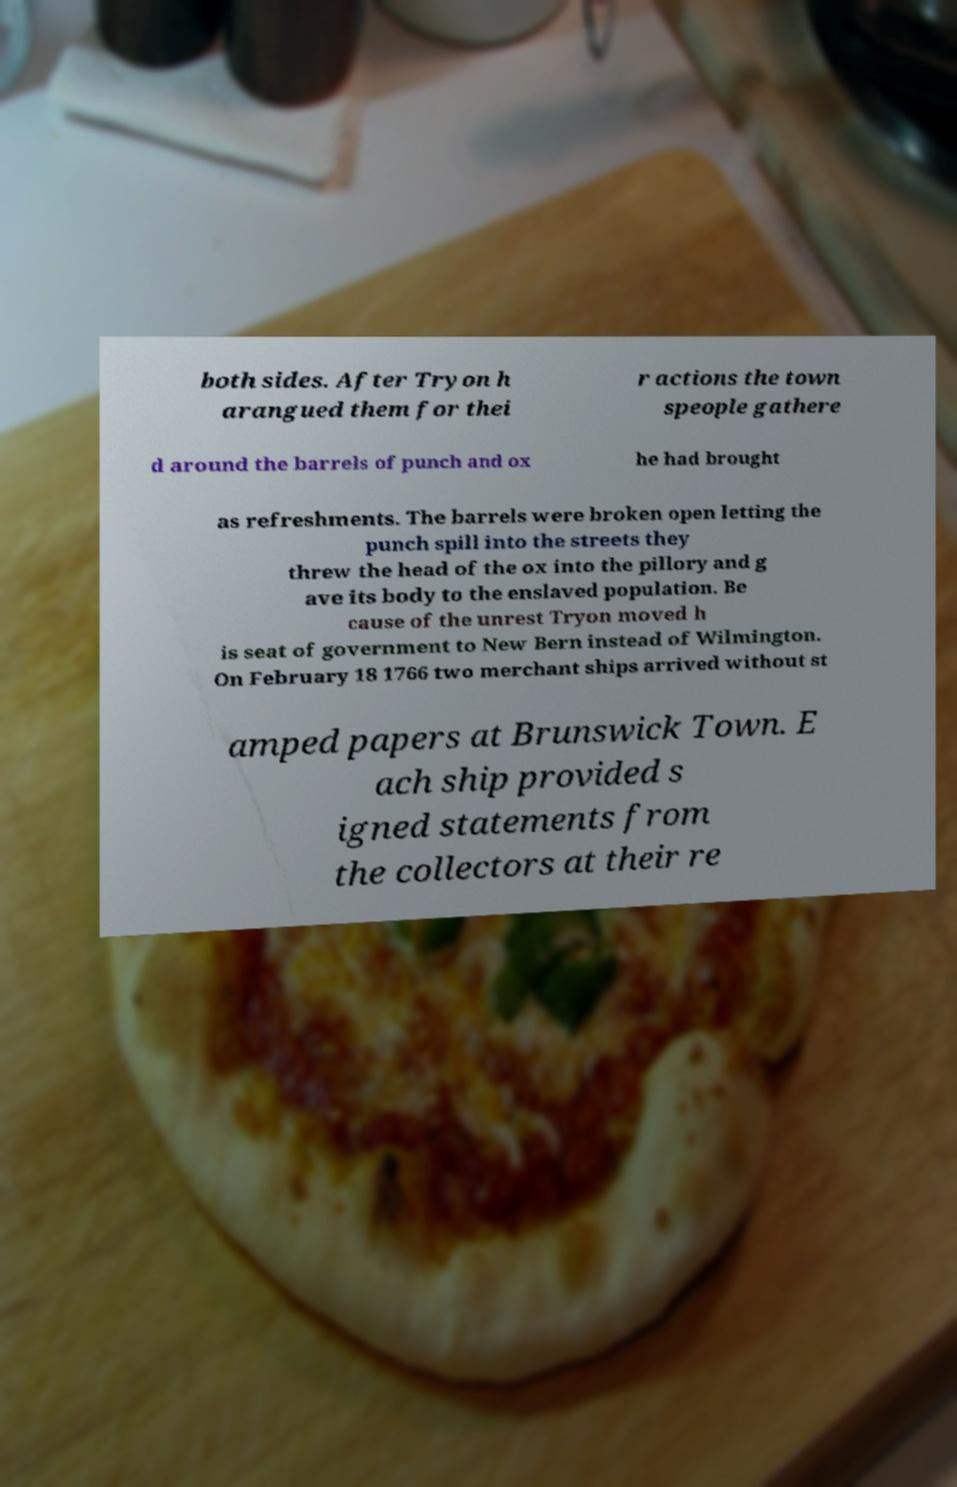For documentation purposes, I need the text within this image transcribed. Could you provide that? both sides. After Tryon h arangued them for thei r actions the town speople gathere d around the barrels of punch and ox he had brought as refreshments. The barrels were broken open letting the punch spill into the streets they threw the head of the ox into the pillory and g ave its body to the enslaved population. Be cause of the unrest Tryon moved h is seat of government to New Bern instead of Wilmington. On February 18 1766 two merchant ships arrived without st amped papers at Brunswick Town. E ach ship provided s igned statements from the collectors at their re 